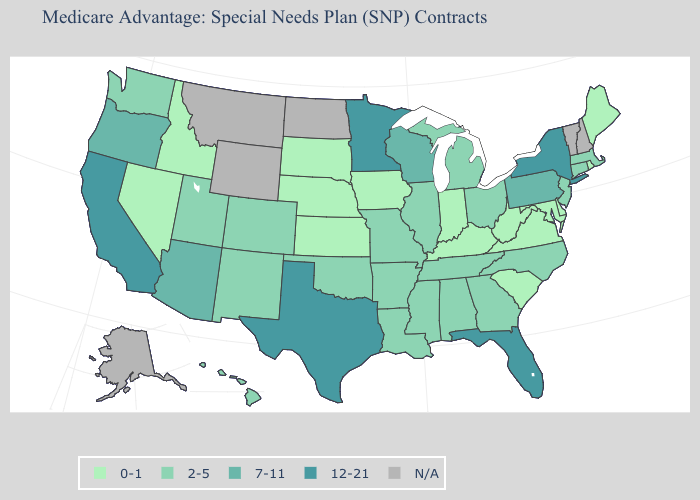How many symbols are there in the legend?
Concise answer only. 5. Does the first symbol in the legend represent the smallest category?
Give a very brief answer. Yes. Name the states that have a value in the range 12-21?
Give a very brief answer. California, Florida, Minnesota, New York, Texas. How many symbols are there in the legend?
Answer briefly. 5. What is the value of Nevada?
Concise answer only. 0-1. What is the value of Arkansas?
Quick response, please. 2-5. What is the value of Connecticut?
Give a very brief answer. 2-5. Name the states that have a value in the range 0-1?
Keep it brief. Delaware, Iowa, Idaho, Indiana, Kansas, Kentucky, Maryland, Maine, Nebraska, Nevada, Rhode Island, South Carolina, South Dakota, Virginia, West Virginia. What is the lowest value in the South?
Be succinct. 0-1. Which states have the highest value in the USA?
Write a very short answer. California, Florida, Minnesota, New York, Texas. Name the states that have a value in the range 0-1?
Be succinct. Delaware, Iowa, Idaho, Indiana, Kansas, Kentucky, Maryland, Maine, Nebraska, Nevada, Rhode Island, South Carolina, South Dakota, Virginia, West Virginia. What is the value of Pennsylvania?
Keep it brief. 7-11. Does the map have missing data?
Be succinct. Yes. 